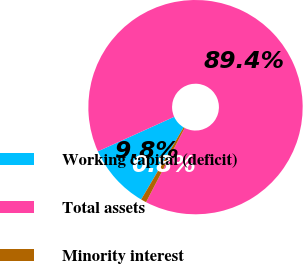<chart> <loc_0><loc_0><loc_500><loc_500><pie_chart><fcel>Working capital (deficit)<fcel>Total assets<fcel>Minority interest<nl><fcel>9.77%<fcel>89.4%<fcel>0.83%<nl></chart> 